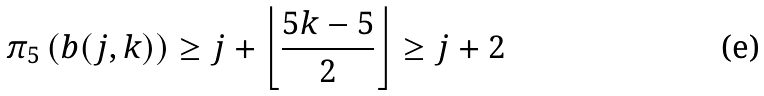<formula> <loc_0><loc_0><loc_500><loc_500>\pi _ { 5 } \left ( b ( j , k ) \right ) \geq j + \left \lfloor \frac { 5 k - 5 } { 2 } \right \rfloor \geq j + 2</formula> 